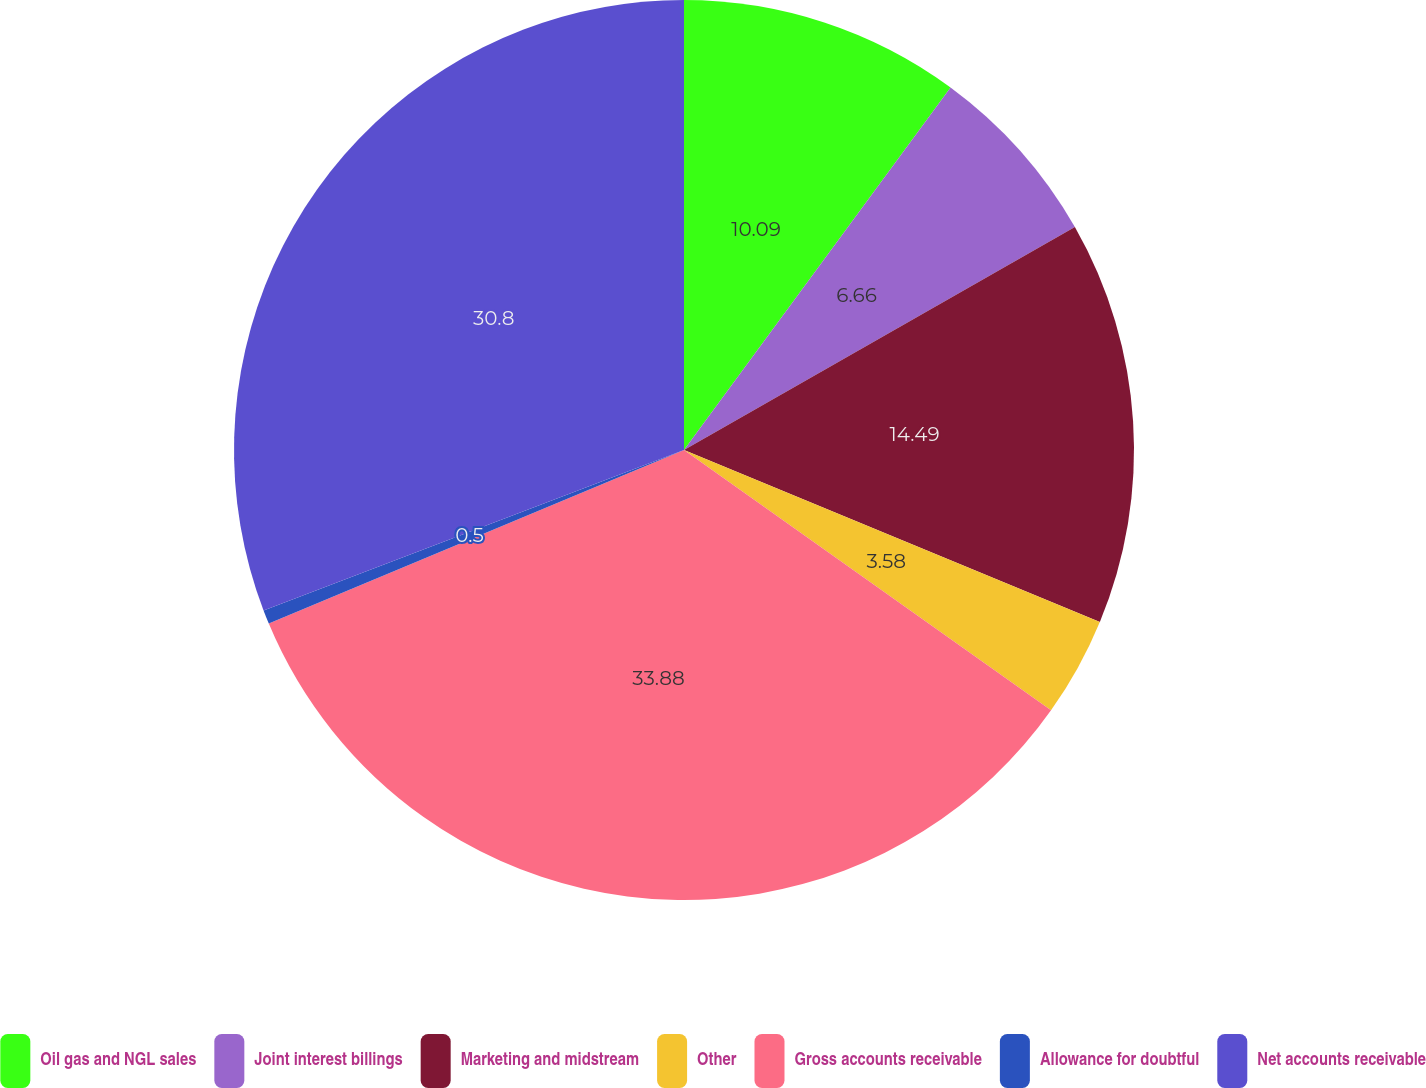Convert chart to OTSL. <chart><loc_0><loc_0><loc_500><loc_500><pie_chart><fcel>Oil gas and NGL sales<fcel>Joint interest billings<fcel>Marketing and midstream<fcel>Other<fcel>Gross accounts receivable<fcel>Allowance for doubtful<fcel>Net accounts receivable<nl><fcel>10.09%<fcel>6.66%<fcel>14.49%<fcel>3.58%<fcel>33.88%<fcel>0.5%<fcel>30.8%<nl></chart> 